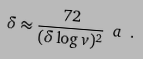Convert formula to latex. <formula><loc_0><loc_0><loc_500><loc_500>\delta \approx \frac { 7 2 } { ( \delta \log v ) ^ { 2 } } \ a \ .</formula> 